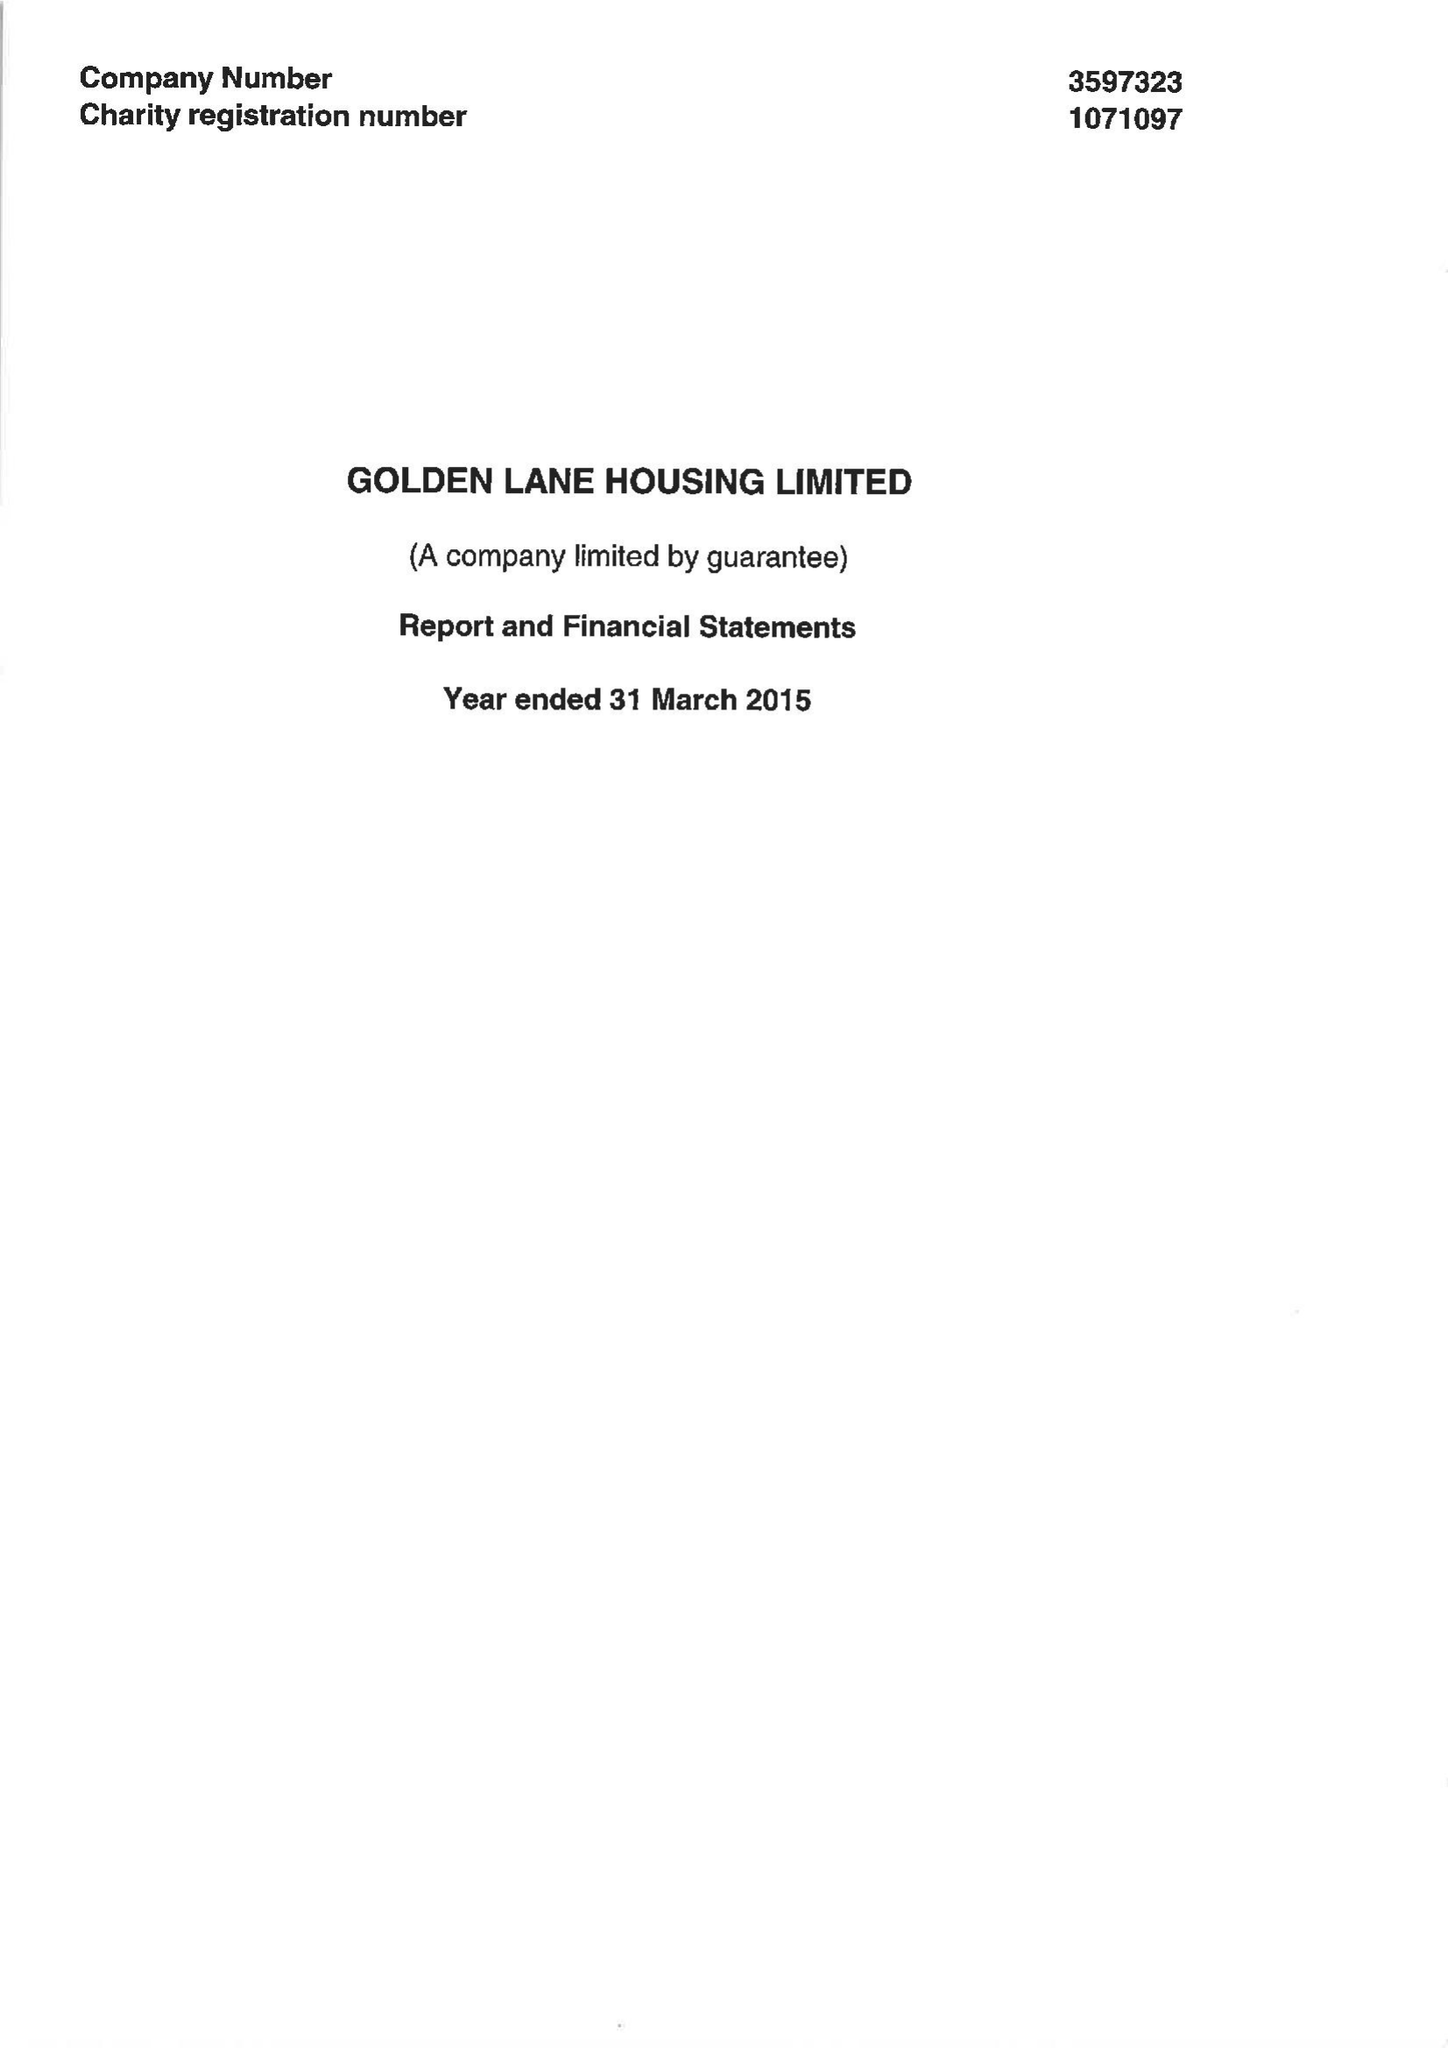What is the value for the spending_annually_in_british_pounds?
Answer the question using a single word or phrase. 10744420.00 